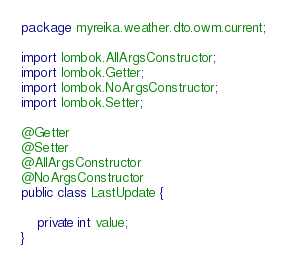Convert code to text. <code><loc_0><loc_0><loc_500><loc_500><_Java_>package myreika.weather.dto.owm.current;

import lombok.AllArgsConstructor;
import lombok.Getter;
import lombok.NoArgsConstructor;
import lombok.Setter;

@Getter
@Setter
@AllArgsConstructor
@NoArgsConstructor
public class LastUpdate {

    private int value;
}
</code> 